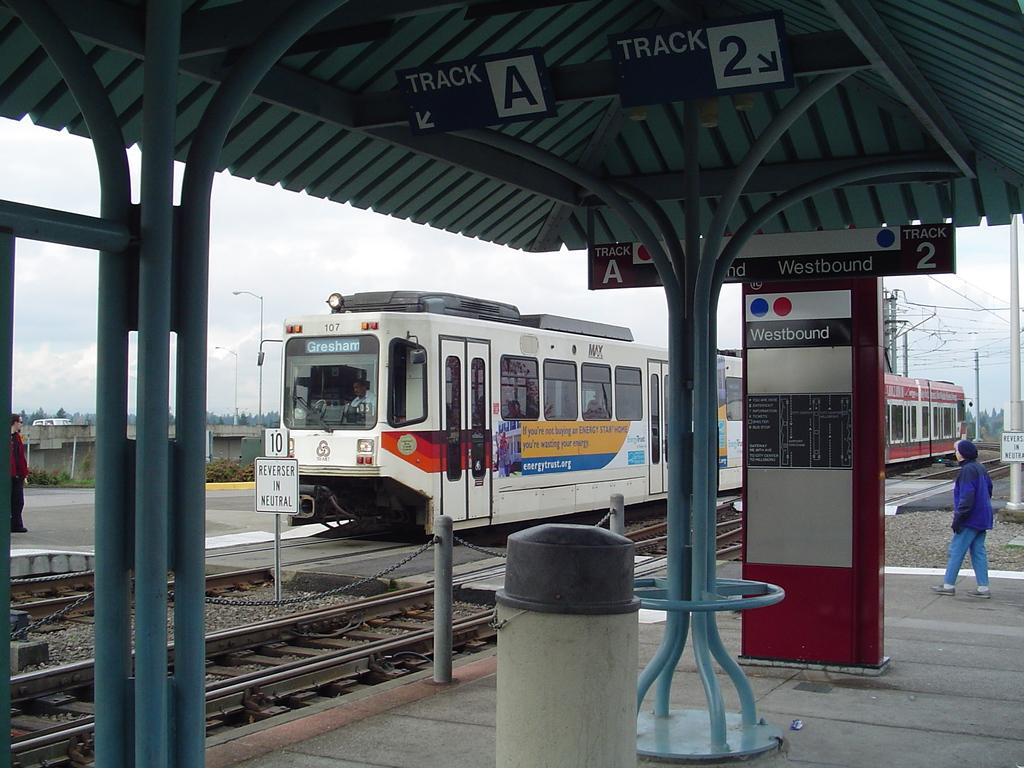Provide a one-sentence caption for the provided image. A train to Gresham is stopped on tracks as a woman approaches. 